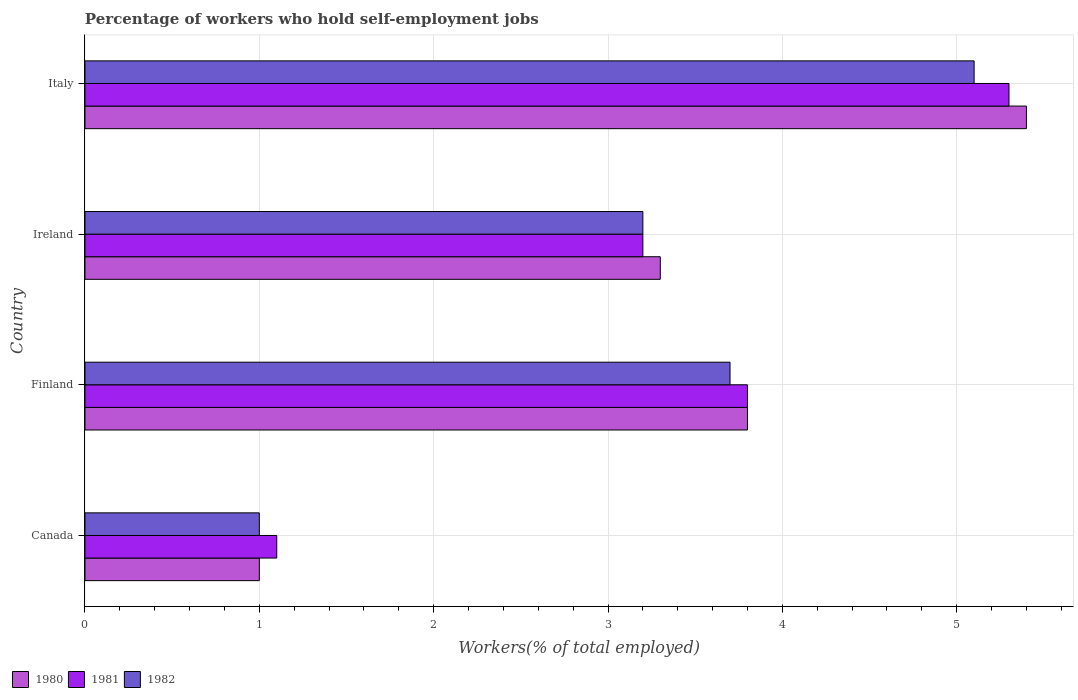How many different coloured bars are there?
Your answer should be compact. 3. Are the number of bars on each tick of the Y-axis equal?
Keep it short and to the point. Yes. What is the label of the 3rd group of bars from the top?
Make the answer very short. Finland. What is the percentage of self-employed workers in 1980 in Italy?
Your response must be concise. 5.4. Across all countries, what is the maximum percentage of self-employed workers in 1981?
Your answer should be very brief. 5.3. In which country was the percentage of self-employed workers in 1981 maximum?
Make the answer very short. Italy. What is the total percentage of self-employed workers in 1981 in the graph?
Keep it short and to the point. 13.4. What is the difference between the percentage of self-employed workers in 1981 in Ireland and that in Italy?
Keep it short and to the point. -2.1. What is the difference between the percentage of self-employed workers in 1982 in Canada and the percentage of self-employed workers in 1980 in Ireland?
Keep it short and to the point. -2.3. What is the average percentage of self-employed workers in 1980 per country?
Your answer should be very brief. 3.37. What is the difference between the percentage of self-employed workers in 1980 and percentage of self-employed workers in 1982 in Ireland?
Your answer should be compact. 0.1. In how many countries, is the percentage of self-employed workers in 1982 greater than 1.8 %?
Your response must be concise. 3. What is the ratio of the percentage of self-employed workers in 1981 in Canada to that in Finland?
Your answer should be very brief. 0.29. Is the percentage of self-employed workers in 1982 in Ireland less than that in Italy?
Your response must be concise. Yes. Is the difference between the percentage of self-employed workers in 1980 in Canada and Finland greater than the difference between the percentage of self-employed workers in 1982 in Canada and Finland?
Your response must be concise. No. What is the difference between the highest and the second highest percentage of self-employed workers in 1982?
Provide a succinct answer. 1.4. What is the difference between the highest and the lowest percentage of self-employed workers in 1981?
Your response must be concise. 4.2. In how many countries, is the percentage of self-employed workers in 1982 greater than the average percentage of self-employed workers in 1982 taken over all countries?
Ensure brevity in your answer.  2. Is it the case that in every country, the sum of the percentage of self-employed workers in 1982 and percentage of self-employed workers in 1981 is greater than the percentage of self-employed workers in 1980?
Keep it short and to the point. Yes. How many countries are there in the graph?
Provide a short and direct response. 4. What is the difference between two consecutive major ticks on the X-axis?
Provide a short and direct response. 1. Are the values on the major ticks of X-axis written in scientific E-notation?
Your answer should be very brief. No. Does the graph contain any zero values?
Your answer should be compact. No. How many legend labels are there?
Keep it short and to the point. 3. How are the legend labels stacked?
Your response must be concise. Horizontal. What is the title of the graph?
Keep it short and to the point. Percentage of workers who hold self-employment jobs. Does "1966" appear as one of the legend labels in the graph?
Your answer should be very brief. No. What is the label or title of the X-axis?
Ensure brevity in your answer.  Workers(% of total employed). What is the label or title of the Y-axis?
Offer a terse response. Country. What is the Workers(% of total employed) in 1980 in Canada?
Make the answer very short. 1. What is the Workers(% of total employed) in 1981 in Canada?
Your response must be concise. 1.1. What is the Workers(% of total employed) of 1980 in Finland?
Give a very brief answer. 3.8. What is the Workers(% of total employed) of 1981 in Finland?
Provide a short and direct response. 3.8. What is the Workers(% of total employed) in 1982 in Finland?
Your response must be concise. 3.7. What is the Workers(% of total employed) in 1980 in Ireland?
Offer a very short reply. 3.3. What is the Workers(% of total employed) in 1981 in Ireland?
Offer a terse response. 3.2. What is the Workers(% of total employed) in 1982 in Ireland?
Your response must be concise. 3.2. What is the Workers(% of total employed) of 1980 in Italy?
Give a very brief answer. 5.4. What is the Workers(% of total employed) of 1981 in Italy?
Offer a very short reply. 5.3. What is the Workers(% of total employed) in 1982 in Italy?
Provide a succinct answer. 5.1. Across all countries, what is the maximum Workers(% of total employed) of 1980?
Provide a short and direct response. 5.4. Across all countries, what is the maximum Workers(% of total employed) in 1981?
Your answer should be compact. 5.3. Across all countries, what is the maximum Workers(% of total employed) of 1982?
Provide a succinct answer. 5.1. Across all countries, what is the minimum Workers(% of total employed) in 1980?
Give a very brief answer. 1. Across all countries, what is the minimum Workers(% of total employed) in 1981?
Keep it short and to the point. 1.1. Across all countries, what is the minimum Workers(% of total employed) of 1982?
Provide a succinct answer. 1. What is the total Workers(% of total employed) of 1981 in the graph?
Your answer should be compact. 13.4. What is the total Workers(% of total employed) of 1982 in the graph?
Your answer should be very brief. 13. What is the difference between the Workers(% of total employed) in 1980 in Canada and that in Ireland?
Keep it short and to the point. -2.3. What is the difference between the Workers(% of total employed) of 1981 in Canada and that in Ireland?
Offer a very short reply. -2.1. What is the difference between the Workers(% of total employed) in 1982 in Canada and that in Ireland?
Make the answer very short. -2.2. What is the difference between the Workers(% of total employed) of 1980 in Canada and that in Italy?
Keep it short and to the point. -4.4. What is the difference between the Workers(% of total employed) of 1982 in Canada and that in Italy?
Give a very brief answer. -4.1. What is the difference between the Workers(% of total employed) in 1980 in Finland and that in Ireland?
Your response must be concise. 0.5. What is the difference between the Workers(% of total employed) in 1982 in Finland and that in Italy?
Ensure brevity in your answer.  -1.4. What is the difference between the Workers(% of total employed) in 1980 in Ireland and that in Italy?
Your response must be concise. -2.1. What is the difference between the Workers(% of total employed) in 1982 in Ireland and that in Italy?
Ensure brevity in your answer.  -1.9. What is the difference between the Workers(% of total employed) of 1980 in Canada and the Workers(% of total employed) of 1981 in Italy?
Keep it short and to the point. -4.3. What is the difference between the Workers(% of total employed) in 1980 in Finland and the Workers(% of total employed) in 1981 in Ireland?
Offer a very short reply. 0.6. What is the difference between the Workers(% of total employed) in 1981 in Finland and the Workers(% of total employed) in 1982 in Italy?
Make the answer very short. -1.3. What is the difference between the Workers(% of total employed) in 1980 in Ireland and the Workers(% of total employed) in 1981 in Italy?
Make the answer very short. -2. What is the average Workers(% of total employed) of 1980 per country?
Provide a short and direct response. 3.38. What is the average Workers(% of total employed) of 1981 per country?
Make the answer very short. 3.35. What is the average Workers(% of total employed) in 1982 per country?
Provide a short and direct response. 3.25. What is the difference between the Workers(% of total employed) of 1980 and Workers(% of total employed) of 1981 in Canada?
Give a very brief answer. -0.1. What is the difference between the Workers(% of total employed) in 1980 and Workers(% of total employed) in 1982 in Canada?
Your response must be concise. 0. What is the difference between the Workers(% of total employed) of 1980 and Workers(% of total employed) of 1981 in Finland?
Provide a succinct answer. 0. What is the difference between the Workers(% of total employed) in 1980 and Workers(% of total employed) in 1982 in Finland?
Ensure brevity in your answer.  0.1. What is the difference between the Workers(% of total employed) in 1980 and Workers(% of total employed) in 1981 in Ireland?
Make the answer very short. 0.1. What is the difference between the Workers(% of total employed) of 1980 and Workers(% of total employed) of 1982 in Ireland?
Ensure brevity in your answer.  0.1. What is the difference between the Workers(% of total employed) of 1981 and Workers(% of total employed) of 1982 in Ireland?
Provide a succinct answer. 0. What is the difference between the Workers(% of total employed) in 1980 and Workers(% of total employed) in 1982 in Italy?
Provide a succinct answer. 0.3. What is the difference between the Workers(% of total employed) of 1981 and Workers(% of total employed) of 1982 in Italy?
Ensure brevity in your answer.  0.2. What is the ratio of the Workers(% of total employed) of 1980 in Canada to that in Finland?
Make the answer very short. 0.26. What is the ratio of the Workers(% of total employed) of 1981 in Canada to that in Finland?
Your response must be concise. 0.29. What is the ratio of the Workers(% of total employed) of 1982 in Canada to that in Finland?
Offer a very short reply. 0.27. What is the ratio of the Workers(% of total employed) of 1980 in Canada to that in Ireland?
Make the answer very short. 0.3. What is the ratio of the Workers(% of total employed) in 1981 in Canada to that in Ireland?
Offer a very short reply. 0.34. What is the ratio of the Workers(% of total employed) in 1982 in Canada to that in Ireland?
Your answer should be compact. 0.31. What is the ratio of the Workers(% of total employed) in 1980 in Canada to that in Italy?
Ensure brevity in your answer.  0.19. What is the ratio of the Workers(% of total employed) in 1981 in Canada to that in Italy?
Make the answer very short. 0.21. What is the ratio of the Workers(% of total employed) of 1982 in Canada to that in Italy?
Your response must be concise. 0.2. What is the ratio of the Workers(% of total employed) in 1980 in Finland to that in Ireland?
Make the answer very short. 1.15. What is the ratio of the Workers(% of total employed) of 1981 in Finland to that in Ireland?
Provide a succinct answer. 1.19. What is the ratio of the Workers(% of total employed) of 1982 in Finland to that in Ireland?
Give a very brief answer. 1.16. What is the ratio of the Workers(% of total employed) of 1980 in Finland to that in Italy?
Keep it short and to the point. 0.7. What is the ratio of the Workers(% of total employed) of 1981 in Finland to that in Italy?
Your answer should be very brief. 0.72. What is the ratio of the Workers(% of total employed) in 1982 in Finland to that in Italy?
Offer a terse response. 0.73. What is the ratio of the Workers(% of total employed) of 1980 in Ireland to that in Italy?
Make the answer very short. 0.61. What is the ratio of the Workers(% of total employed) of 1981 in Ireland to that in Italy?
Keep it short and to the point. 0.6. What is the ratio of the Workers(% of total employed) of 1982 in Ireland to that in Italy?
Offer a very short reply. 0.63. What is the difference between the highest and the second highest Workers(% of total employed) of 1980?
Provide a succinct answer. 1.6. What is the difference between the highest and the second highest Workers(% of total employed) in 1981?
Ensure brevity in your answer.  1.5. What is the difference between the highest and the lowest Workers(% of total employed) in 1980?
Make the answer very short. 4.4. 